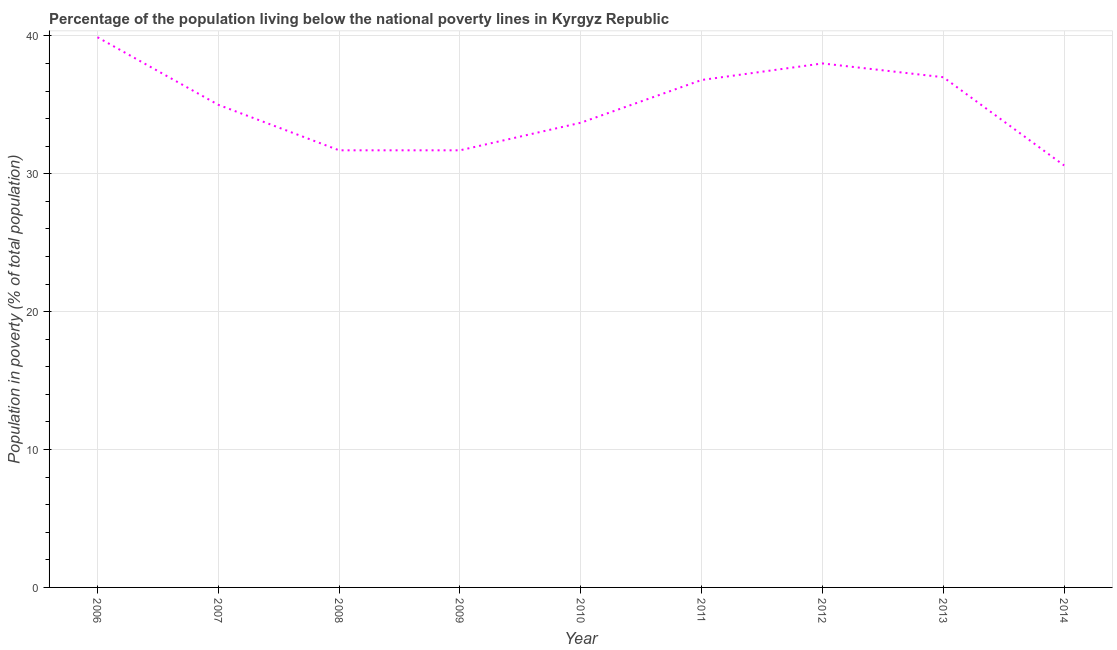What is the percentage of population living below poverty line in 2011?
Your response must be concise. 36.8. Across all years, what is the maximum percentage of population living below poverty line?
Ensure brevity in your answer.  39.9. Across all years, what is the minimum percentage of population living below poverty line?
Make the answer very short. 30.6. In which year was the percentage of population living below poverty line maximum?
Provide a short and direct response. 2006. In which year was the percentage of population living below poverty line minimum?
Your answer should be very brief. 2014. What is the sum of the percentage of population living below poverty line?
Your response must be concise. 314.4. What is the difference between the percentage of population living below poverty line in 2009 and 2012?
Ensure brevity in your answer.  -6.3. What is the average percentage of population living below poverty line per year?
Your answer should be compact. 34.93. In how many years, is the percentage of population living below poverty line greater than 22 %?
Provide a succinct answer. 9. Do a majority of the years between 2006 and 2008 (inclusive) have percentage of population living below poverty line greater than 4 %?
Your response must be concise. Yes. What is the ratio of the percentage of population living below poverty line in 2010 to that in 2012?
Keep it short and to the point. 0.89. What is the difference between the highest and the second highest percentage of population living below poverty line?
Your response must be concise. 1.9. What is the difference between the highest and the lowest percentage of population living below poverty line?
Provide a short and direct response. 9.3. In how many years, is the percentage of population living below poverty line greater than the average percentage of population living below poverty line taken over all years?
Ensure brevity in your answer.  5. What is the difference between two consecutive major ticks on the Y-axis?
Offer a terse response. 10. Are the values on the major ticks of Y-axis written in scientific E-notation?
Ensure brevity in your answer.  No. Does the graph contain grids?
Give a very brief answer. Yes. What is the title of the graph?
Keep it short and to the point. Percentage of the population living below the national poverty lines in Kyrgyz Republic. What is the label or title of the Y-axis?
Keep it short and to the point. Population in poverty (% of total population). What is the Population in poverty (% of total population) of 2006?
Your response must be concise. 39.9. What is the Population in poverty (% of total population) in 2008?
Offer a very short reply. 31.7. What is the Population in poverty (% of total population) of 2009?
Provide a short and direct response. 31.7. What is the Population in poverty (% of total population) in 2010?
Provide a succinct answer. 33.7. What is the Population in poverty (% of total population) in 2011?
Give a very brief answer. 36.8. What is the Population in poverty (% of total population) of 2014?
Your answer should be very brief. 30.6. What is the difference between the Population in poverty (% of total population) in 2006 and 2008?
Your response must be concise. 8.2. What is the difference between the Population in poverty (% of total population) in 2006 and 2009?
Your answer should be compact. 8.2. What is the difference between the Population in poverty (% of total population) in 2006 and 2011?
Your answer should be very brief. 3.1. What is the difference between the Population in poverty (% of total population) in 2006 and 2012?
Offer a terse response. 1.9. What is the difference between the Population in poverty (% of total population) in 2006 and 2014?
Offer a terse response. 9.3. What is the difference between the Population in poverty (% of total population) in 2007 and 2008?
Give a very brief answer. 3.3. What is the difference between the Population in poverty (% of total population) in 2007 and 2010?
Your answer should be compact. 1.3. What is the difference between the Population in poverty (% of total population) in 2007 and 2011?
Offer a terse response. -1.8. What is the difference between the Population in poverty (% of total population) in 2008 and 2009?
Your response must be concise. 0. What is the difference between the Population in poverty (% of total population) in 2008 and 2010?
Give a very brief answer. -2. What is the difference between the Population in poverty (% of total population) in 2008 and 2012?
Give a very brief answer. -6.3. What is the difference between the Population in poverty (% of total population) in 2008 and 2013?
Give a very brief answer. -5.3. What is the difference between the Population in poverty (% of total population) in 2008 and 2014?
Keep it short and to the point. 1.1. What is the difference between the Population in poverty (% of total population) in 2009 and 2012?
Make the answer very short. -6.3. What is the difference between the Population in poverty (% of total population) in 2009 and 2014?
Give a very brief answer. 1.1. What is the difference between the Population in poverty (% of total population) in 2010 and 2011?
Your answer should be compact. -3.1. What is the difference between the Population in poverty (% of total population) in 2010 and 2014?
Keep it short and to the point. 3.1. What is the difference between the Population in poverty (% of total population) in 2011 and 2013?
Make the answer very short. -0.2. What is the difference between the Population in poverty (% of total population) in 2011 and 2014?
Keep it short and to the point. 6.2. What is the difference between the Population in poverty (% of total population) in 2012 and 2014?
Provide a succinct answer. 7.4. What is the ratio of the Population in poverty (% of total population) in 2006 to that in 2007?
Give a very brief answer. 1.14. What is the ratio of the Population in poverty (% of total population) in 2006 to that in 2008?
Offer a very short reply. 1.26. What is the ratio of the Population in poverty (% of total population) in 2006 to that in 2009?
Provide a short and direct response. 1.26. What is the ratio of the Population in poverty (% of total population) in 2006 to that in 2010?
Your answer should be compact. 1.18. What is the ratio of the Population in poverty (% of total population) in 2006 to that in 2011?
Keep it short and to the point. 1.08. What is the ratio of the Population in poverty (% of total population) in 2006 to that in 2012?
Make the answer very short. 1.05. What is the ratio of the Population in poverty (% of total population) in 2006 to that in 2013?
Ensure brevity in your answer.  1.08. What is the ratio of the Population in poverty (% of total population) in 2006 to that in 2014?
Make the answer very short. 1.3. What is the ratio of the Population in poverty (% of total population) in 2007 to that in 2008?
Provide a succinct answer. 1.1. What is the ratio of the Population in poverty (% of total population) in 2007 to that in 2009?
Keep it short and to the point. 1.1. What is the ratio of the Population in poverty (% of total population) in 2007 to that in 2010?
Provide a short and direct response. 1.04. What is the ratio of the Population in poverty (% of total population) in 2007 to that in 2011?
Ensure brevity in your answer.  0.95. What is the ratio of the Population in poverty (% of total population) in 2007 to that in 2012?
Provide a succinct answer. 0.92. What is the ratio of the Population in poverty (% of total population) in 2007 to that in 2013?
Offer a very short reply. 0.95. What is the ratio of the Population in poverty (% of total population) in 2007 to that in 2014?
Ensure brevity in your answer.  1.14. What is the ratio of the Population in poverty (% of total population) in 2008 to that in 2010?
Keep it short and to the point. 0.94. What is the ratio of the Population in poverty (% of total population) in 2008 to that in 2011?
Your response must be concise. 0.86. What is the ratio of the Population in poverty (% of total population) in 2008 to that in 2012?
Give a very brief answer. 0.83. What is the ratio of the Population in poverty (% of total population) in 2008 to that in 2013?
Provide a succinct answer. 0.86. What is the ratio of the Population in poverty (% of total population) in 2008 to that in 2014?
Make the answer very short. 1.04. What is the ratio of the Population in poverty (% of total population) in 2009 to that in 2010?
Your answer should be compact. 0.94. What is the ratio of the Population in poverty (% of total population) in 2009 to that in 2011?
Offer a terse response. 0.86. What is the ratio of the Population in poverty (% of total population) in 2009 to that in 2012?
Your answer should be compact. 0.83. What is the ratio of the Population in poverty (% of total population) in 2009 to that in 2013?
Offer a terse response. 0.86. What is the ratio of the Population in poverty (% of total population) in 2009 to that in 2014?
Your answer should be very brief. 1.04. What is the ratio of the Population in poverty (% of total population) in 2010 to that in 2011?
Provide a short and direct response. 0.92. What is the ratio of the Population in poverty (% of total population) in 2010 to that in 2012?
Keep it short and to the point. 0.89. What is the ratio of the Population in poverty (% of total population) in 2010 to that in 2013?
Ensure brevity in your answer.  0.91. What is the ratio of the Population in poverty (% of total population) in 2010 to that in 2014?
Your response must be concise. 1.1. What is the ratio of the Population in poverty (% of total population) in 2011 to that in 2013?
Give a very brief answer. 0.99. What is the ratio of the Population in poverty (% of total population) in 2011 to that in 2014?
Your answer should be very brief. 1.2. What is the ratio of the Population in poverty (% of total population) in 2012 to that in 2014?
Offer a terse response. 1.24. What is the ratio of the Population in poverty (% of total population) in 2013 to that in 2014?
Your response must be concise. 1.21. 